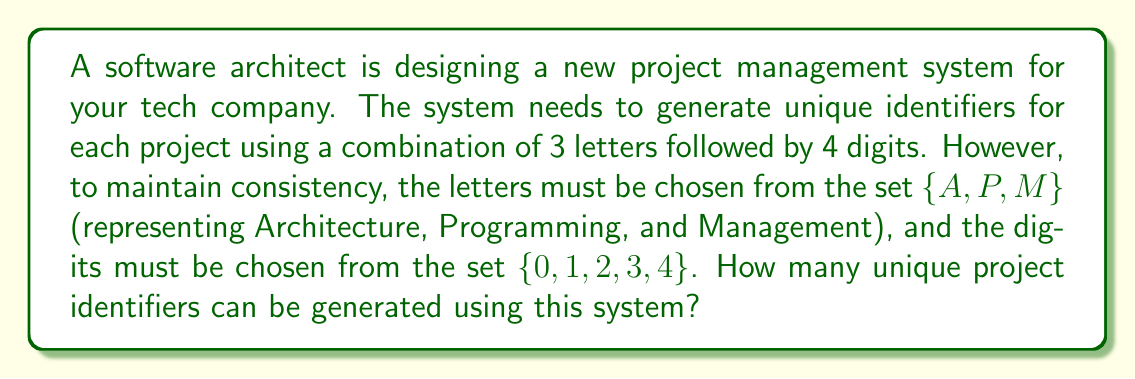What is the answer to this math problem? To solve this problem, we'll use the fundamental counting principle and permutation concepts from abstract algebra. Let's break it down step-by-step:

1. For the letter part:
   - We have 3 choices for each of the 3 letter positions.
   - This is a permutation with repetition allowed.
   - Number of letter combinations: $3^3 = 27$

2. For the digit part:
   - We have 5 choices for each of the 4 digit positions.
   - This is also a permutation with repetition allowed.
   - Number of digit combinations: $5^4 = 625$

3. To get the total number of unique identifiers:
   - We multiply the number of letter combinations by the number of digit combinations.
   - Total combinations = $27 \times 625$

4. Calculating the final result:
   $$27 \times 625 = 16,875$$

Therefore, the number of unique project identifiers that can be generated is 16,875.

This approach ensures that every possible combination of the allowed letters and digits is accounted for, providing the maximum number of unique identifiers within the given constraints.
Answer: 16,875 unique project identifiers 